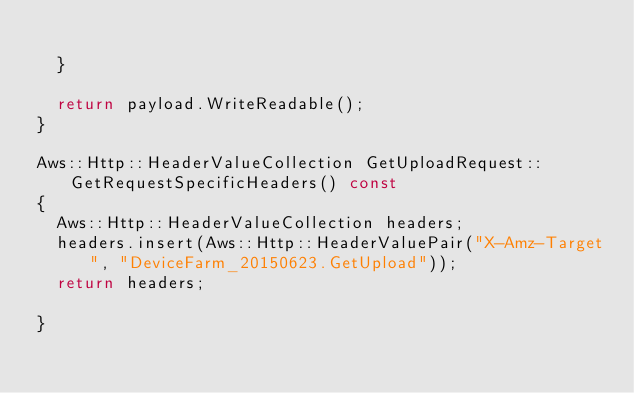<code> <loc_0><loc_0><loc_500><loc_500><_C++_>
  }

  return payload.WriteReadable();
}

Aws::Http::HeaderValueCollection GetUploadRequest::GetRequestSpecificHeaders() const
{
  Aws::Http::HeaderValueCollection headers;
  headers.insert(Aws::Http::HeaderValuePair("X-Amz-Target", "DeviceFarm_20150623.GetUpload"));
  return headers;

}



</code> 